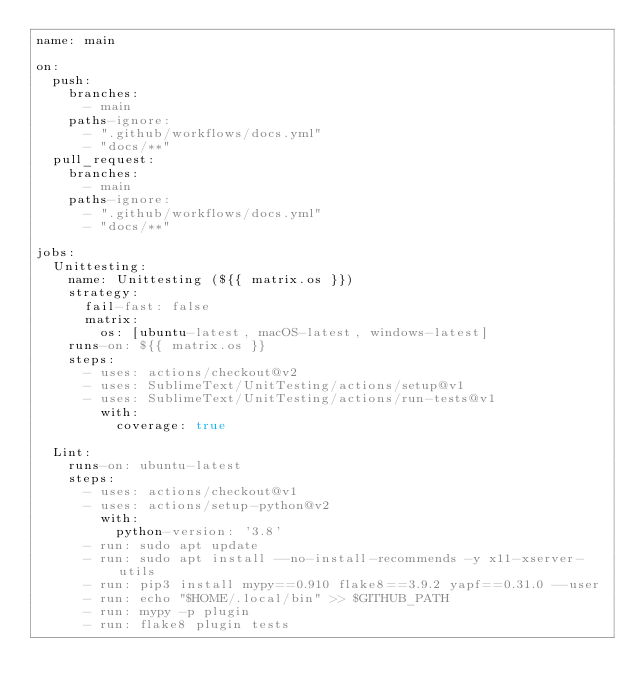Convert code to text. <code><loc_0><loc_0><loc_500><loc_500><_YAML_>name: main

on:
  push:
    branches:
      - main
    paths-ignore:
      - ".github/workflows/docs.yml"
      - "docs/**"
  pull_request:
    branches:
      - main
    paths-ignore:
      - ".github/workflows/docs.yml"
      - "docs/**"

jobs:
  Unittesting:
    name: Unittesting (${{ matrix.os }})
    strategy:
      fail-fast: false
      matrix:
        os: [ubuntu-latest, macOS-latest, windows-latest]
    runs-on: ${{ matrix.os }}
    steps:
      - uses: actions/checkout@v2
      - uses: SublimeText/UnitTesting/actions/setup@v1
      - uses: SublimeText/UnitTesting/actions/run-tests@v1
        with:
          coverage: true

  Lint:
    runs-on: ubuntu-latest
    steps:
      - uses: actions/checkout@v1
      - uses: actions/setup-python@v2
        with:
          python-version: '3.8'
      - run: sudo apt update
      - run: sudo apt install --no-install-recommends -y x11-xserver-utils
      - run: pip3 install mypy==0.910 flake8==3.9.2 yapf==0.31.0 --user
      - run: echo "$HOME/.local/bin" >> $GITHUB_PATH
      - run: mypy -p plugin
      - run: flake8 plugin tests
</code> 